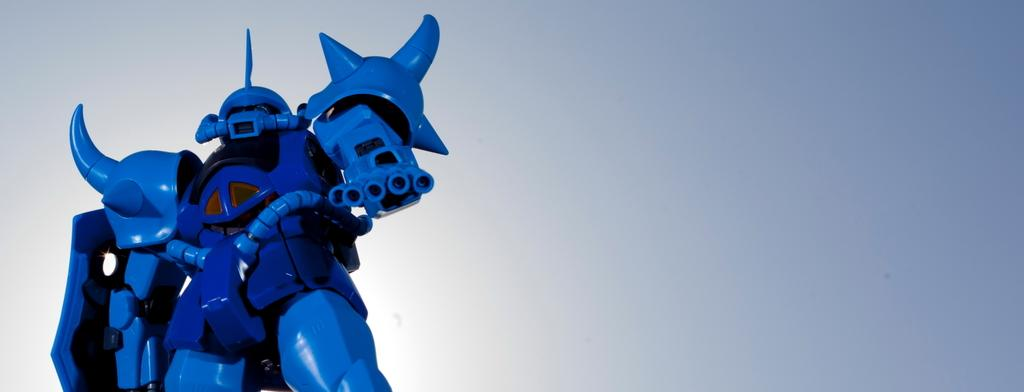What is the main subject of the picture? The main subject of the picture is a robot. Where is the robot located in the image? The robot is towards the left side of the image. What color is the robot? The robot is blue in color. What type of soup is the robot holding in the image? There is no soup present in the image; the robot is the main subject. 